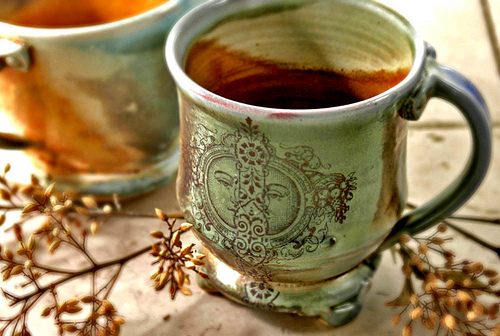<image>
Is there a cup next to the coffee? No. The cup is not positioned next to the coffee. They are located in different areas of the scene. Where is the stem in relation to the cup? Is it to the left of the cup? Yes. From this viewpoint, the stem is positioned to the left side relative to the cup. 